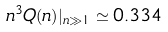<formula> <loc_0><loc_0><loc_500><loc_500>n ^ { 3 } Q ( n ) | _ { n \gg 1 } \simeq 0 . 3 3 4</formula> 